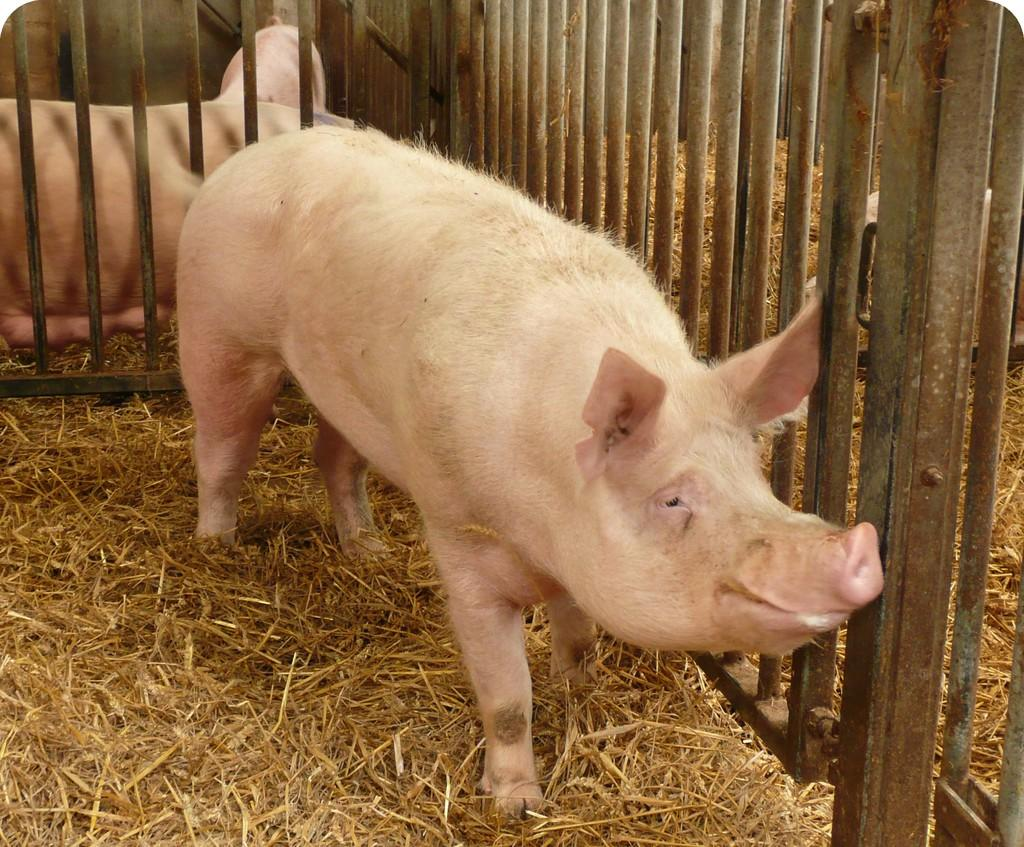What animals can be seen on the ground in the image? There are pigs on the ground in the image. What type of barrier is visible in the image? There is a fence visible in the image. What type of vegetation is present in the image? Dried grass is present in the image. What type of steel structure can be seen in the image? There is no steel structure present in the image; it features pigs on the ground, a fence, and dried grass. Can you identify the brain activity of the pigs in the image? There is no way to determine the brain activity of the pigs from the image, as it only shows their physical appearance and location. 